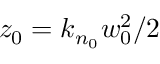<formula> <loc_0><loc_0><loc_500><loc_500>z _ { 0 } = k _ { n _ { 0 } } w _ { 0 } ^ { 2 } / 2</formula> 